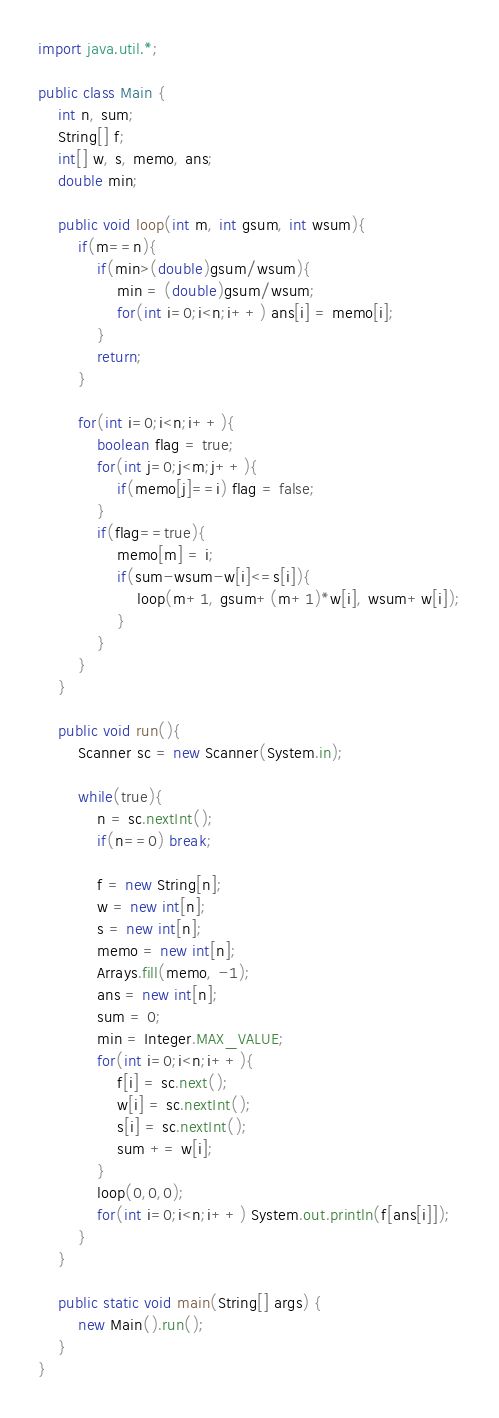<code> <loc_0><loc_0><loc_500><loc_500><_Java_>import java.util.*;

public class Main {
	int n, sum;
	String[] f;
	int[] w, s, memo, ans;
	double min;
	
	public void loop(int m, int gsum, int wsum){
		if(m==n){
			if(min>(double)gsum/wsum){
				min = (double)gsum/wsum;
				for(int i=0;i<n;i++) ans[i] = memo[i];
			}
			return;
		}
		
		for(int i=0;i<n;i++){
			boolean flag = true;
			for(int j=0;j<m;j++){
				if(memo[j]==i) flag = false;
			}
			if(flag==true){
				memo[m] = i;
				if(sum-wsum-w[i]<=s[i]){
					loop(m+1, gsum+(m+1)*w[i], wsum+w[i]);
				}
			}
		}
	}
	
	public void run(){
		Scanner sc = new Scanner(System.in);
		
		while(true){
			n = sc.nextInt();
			if(n==0) break;
			
			f = new String[n];
			w = new int[n];
			s = new int[n];
			memo = new int[n];
			Arrays.fill(memo, -1);
			ans = new int[n];
			sum = 0;
			min = Integer.MAX_VALUE;
			for(int i=0;i<n;i++){
				f[i] = sc.next();
				w[i] = sc.nextInt();
				s[i] = sc.nextInt();
				sum += w[i];
			}
			loop(0,0,0);
			for(int i=0;i<n;i++) System.out.println(f[ans[i]]);
		}
	}
	
	public static void main(String[] args) {
		new Main().run();
	}
}</code> 